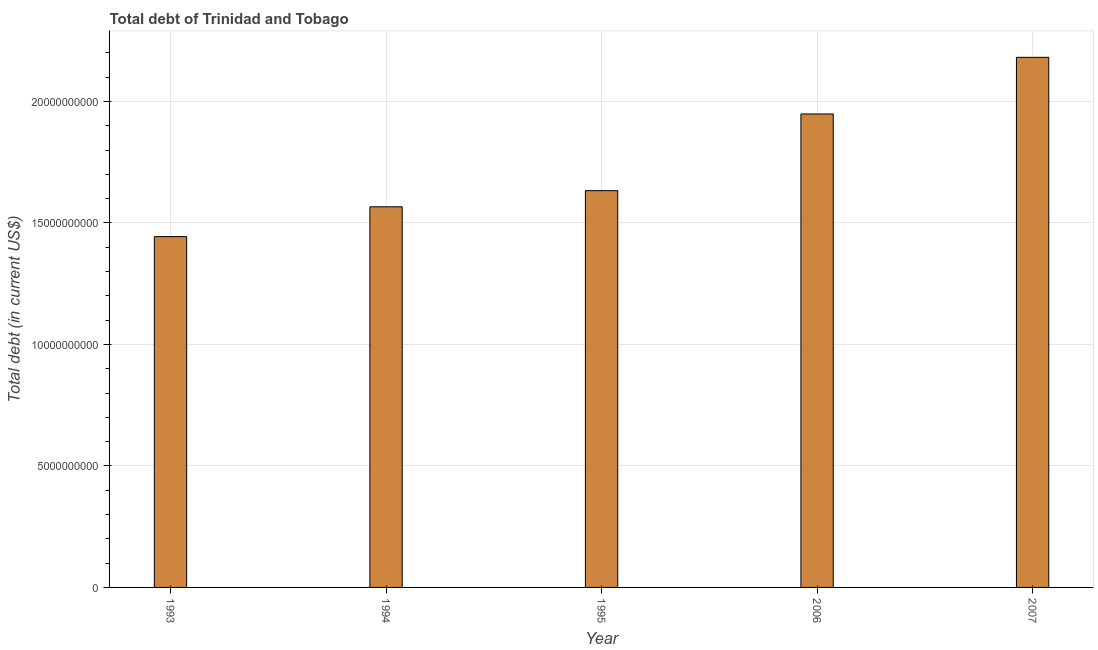Does the graph contain any zero values?
Offer a very short reply. No. What is the title of the graph?
Your response must be concise. Total debt of Trinidad and Tobago. What is the label or title of the X-axis?
Keep it short and to the point. Year. What is the label or title of the Y-axis?
Your response must be concise. Total debt (in current US$). What is the total debt in 1993?
Keep it short and to the point. 1.44e+1. Across all years, what is the maximum total debt?
Your answer should be very brief. 2.18e+1. Across all years, what is the minimum total debt?
Your answer should be very brief. 1.44e+1. What is the sum of the total debt?
Provide a succinct answer. 8.77e+1. What is the difference between the total debt in 1993 and 2007?
Your answer should be compact. -7.38e+09. What is the average total debt per year?
Ensure brevity in your answer.  1.75e+1. What is the median total debt?
Offer a very short reply. 1.63e+1. What is the ratio of the total debt in 1993 to that in 1994?
Offer a very short reply. 0.92. Is the difference between the total debt in 1995 and 2006 greater than the difference between any two years?
Keep it short and to the point. No. What is the difference between the highest and the second highest total debt?
Ensure brevity in your answer.  2.33e+09. What is the difference between the highest and the lowest total debt?
Provide a succinct answer. 7.38e+09. In how many years, is the total debt greater than the average total debt taken over all years?
Offer a terse response. 2. How many bars are there?
Your response must be concise. 5. Are all the bars in the graph horizontal?
Keep it short and to the point. No. What is the difference between two consecutive major ticks on the Y-axis?
Provide a succinct answer. 5.00e+09. What is the Total debt (in current US$) in 1993?
Keep it short and to the point. 1.44e+1. What is the Total debt (in current US$) in 1994?
Your answer should be very brief. 1.57e+1. What is the Total debt (in current US$) in 1995?
Offer a very short reply. 1.63e+1. What is the Total debt (in current US$) in 2006?
Offer a very short reply. 1.95e+1. What is the Total debt (in current US$) in 2007?
Keep it short and to the point. 2.18e+1. What is the difference between the Total debt (in current US$) in 1993 and 1994?
Provide a succinct answer. -1.23e+09. What is the difference between the Total debt (in current US$) in 1993 and 1995?
Give a very brief answer. -1.89e+09. What is the difference between the Total debt (in current US$) in 1993 and 2006?
Give a very brief answer. -5.05e+09. What is the difference between the Total debt (in current US$) in 1993 and 2007?
Make the answer very short. -7.38e+09. What is the difference between the Total debt (in current US$) in 1994 and 1995?
Provide a succinct answer. -6.64e+08. What is the difference between the Total debt (in current US$) in 1994 and 2006?
Provide a succinct answer. -3.82e+09. What is the difference between the Total debt (in current US$) in 1994 and 2007?
Make the answer very short. -6.15e+09. What is the difference between the Total debt (in current US$) in 1995 and 2006?
Give a very brief answer. -3.16e+09. What is the difference between the Total debt (in current US$) in 1995 and 2007?
Keep it short and to the point. -5.49e+09. What is the difference between the Total debt (in current US$) in 2006 and 2007?
Your answer should be very brief. -2.33e+09. What is the ratio of the Total debt (in current US$) in 1993 to that in 1994?
Offer a terse response. 0.92. What is the ratio of the Total debt (in current US$) in 1993 to that in 1995?
Your response must be concise. 0.88. What is the ratio of the Total debt (in current US$) in 1993 to that in 2006?
Your response must be concise. 0.74. What is the ratio of the Total debt (in current US$) in 1993 to that in 2007?
Ensure brevity in your answer.  0.66. What is the ratio of the Total debt (in current US$) in 1994 to that in 1995?
Offer a very short reply. 0.96. What is the ratio of the Total debt (in current US$) in 1994 to that in 2006?
Offer a terse response. 0.8. What is the ratio of the Total debt (in current US$) in 1994 to that in 2007?
Provide a succinct answer. 0.72. What is the ratio of the Total debt (in current US$) in 1995 to that in 2006?
Make the answer very short. 0.84. What is the ratio of the Total debt (in current US$) in 1995 to that in 2007?
Provide a short and direct response. 0.75. What is the ratio of the Total debt (in current US$) in 2006 to that in 2007?
Your response must be concise. 0.89. 